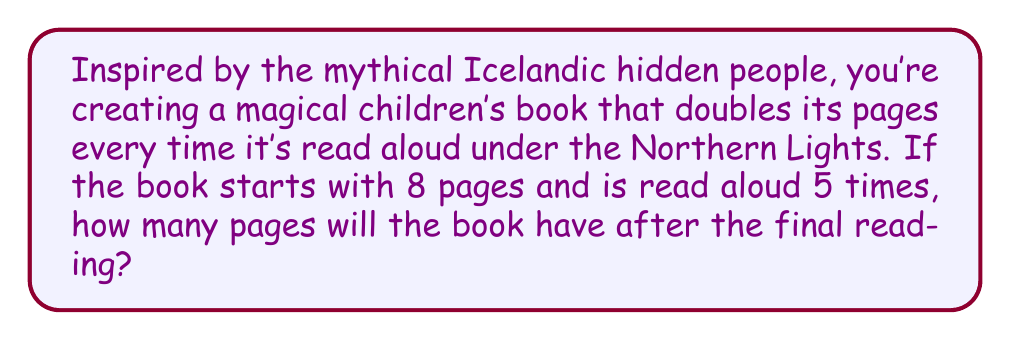Show me your answer to this math problem. Let's approach this step-by-step:

1) We start with 8 pages and the book doubles its pages 5 times.

2) This can be represented as an exponential equation:
   $$ 8 \cdot 2^5 $$

3) Let's break this down:
   - 8 is our starting number of pages
   - 2 is our growth factor (doubling each time)
   - 5 is the number of times the doubling occurs

4) Now, let's solve:
   $$ 8 \cdot 2^5 = 8 \cdot 32 $$

5) To calculate $2^5$:
   $$ 2^5 = 2 \cdot 2 \cdot 2 \cdot 2 \cdot 2 = 32 $$

6) Finally, multiply:
   $$ 8 \cdot 32 = 256 $$

Therefore, after being read aloud 5 times under the Northern Lights, the magical book will have 256 pages.
Answer: 256 pages 